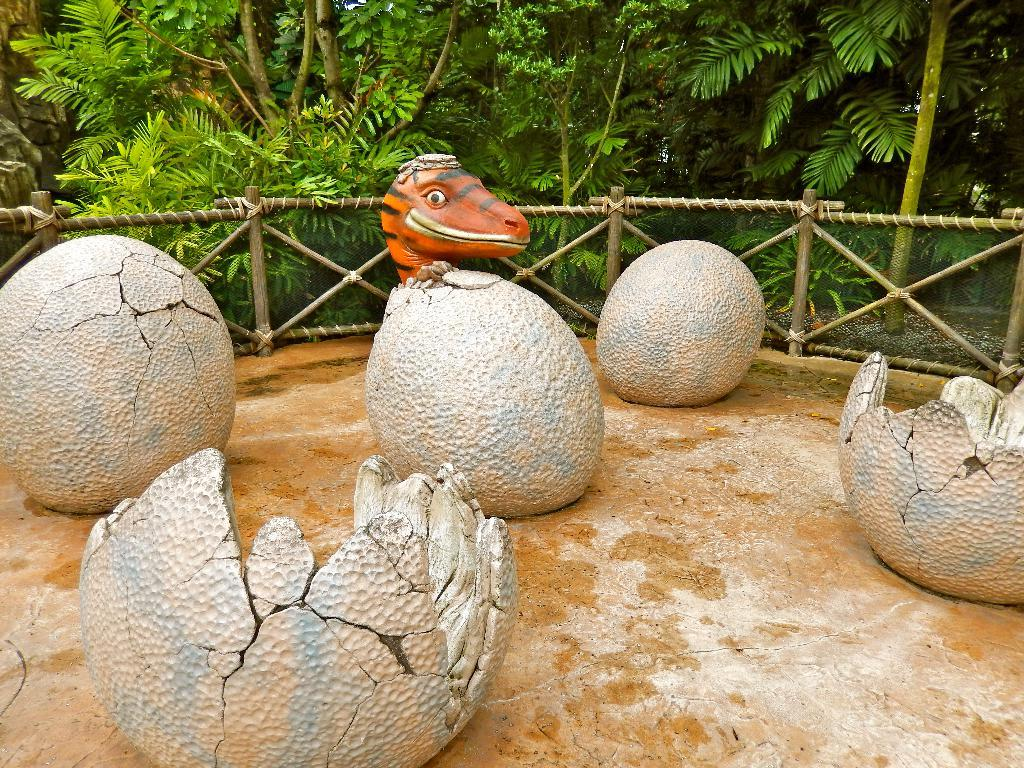What is the main subject in the foreground of the image? There are structures of eggs in the foreground of the image. What is the state of some eggs in the image? Some eggs are hatched in the image. What is happening with one of the eggs in the image? An animal is coming out of an egg in the image. What can be seen in the background of the image? There is a fence and trees in the background of the image. What type of ghost can be seen interacting with the eggs in the image? There is no ghost present in the image; it features structures of eggs and an animal coming out of one of them. What type of quince is being used to hatch the eggs in the image? There is no quince present in the image, and eggs are not hatched by using quince. 